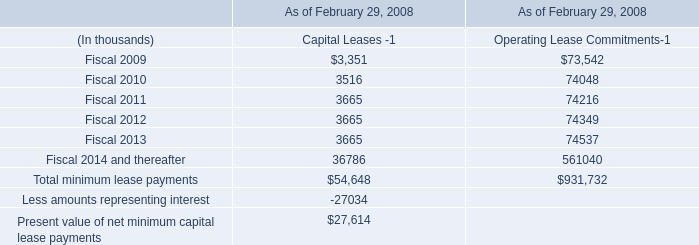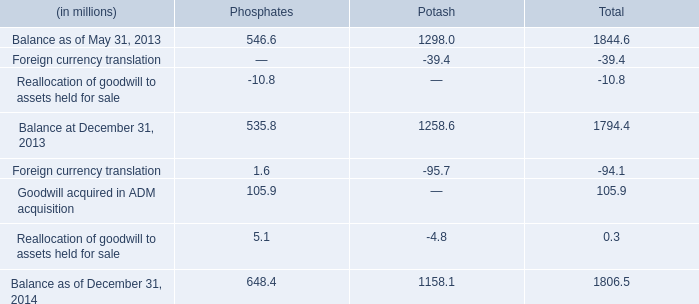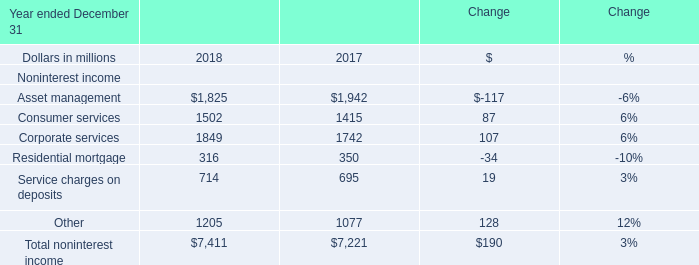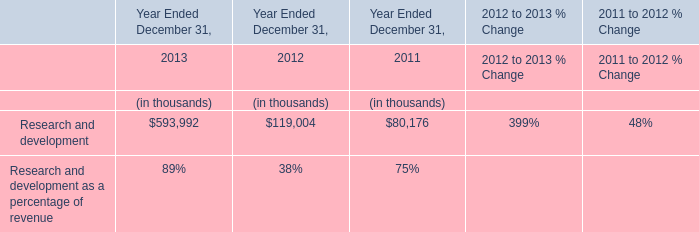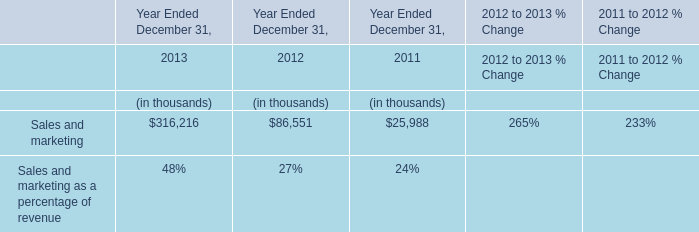What's the sum of Balance as of December 31, 2014 of Potash, Corporate services of Change 2018, and Balance at December 31, 2013 of Total ? 
Computations: ((1158.1 + 1849.0) + 1794.4)
Answer: 4801.5. 